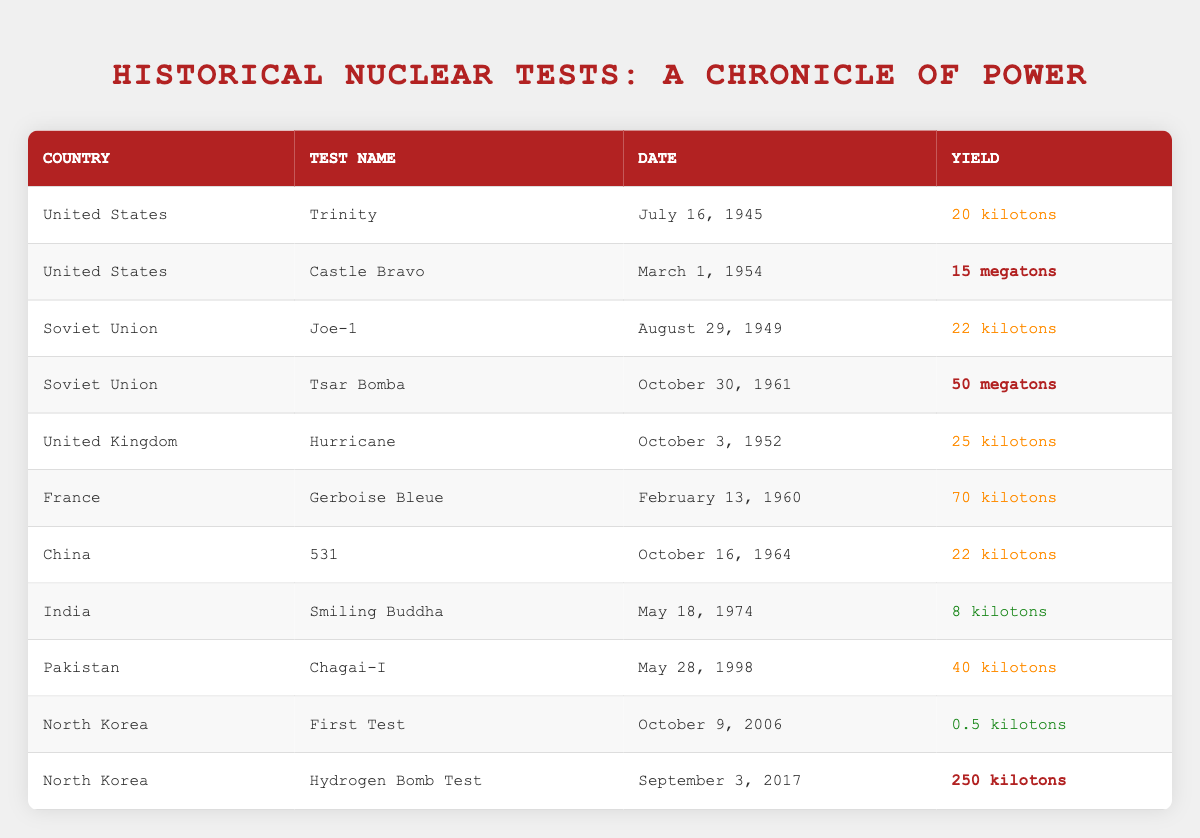What country conducted the first nuclear test? The first nuclear test listed in the table was the "Trinity" test conducted by the United States on July 16, 1945.
Answer: United States What is the yield of the "Tsar Bomba"? The yield of the "Tsar Bomba" test conducted by the Soviet Union on October 30, 1961, is 50 megatons.
Answer: 50 megatons Which test had the lowest yield? The "First Test" conducted by North Korea on October 9, 2006, had the lowest yield of 0.5 kilotons.
Answer: 0.5 kilotons What was the total yield of the tests conducted by the United States in the table? The total yield for U.S. tests is 20 kilotons (Trinity) + 15 megatons (Castle Bravo, converted to kilotons, is 15,000 kilotons), making a total of 15,020 kilotons.
Answer: 15,020 kilotons Is the yield of the "Hurricane" test greater than 20 kilotons? Yes, the "Hurricane" test has a yield of 25 kilotons, which is greater than 20 kilotons.
Answer: Yes What country tested a nuclear bomb with a yield exceeding 40 kilotons? The countries that tested bombs with yields exceeding 40 kilotons are the Soviet Union (Tsar Bomba, 50 megatons), France (Gerboise Bleue, 70 kilotons), and Pakistan (Chagai-I, 40 kilotons).
Answer: Soviet Union, France, Pakistan What is the average yield of all North Korean tests listed? There are two North Korean tests with yields of 0.5 kilotons (First Test) and 0.25 megatons (Hydrogen Bomb Test, converted to kilotons is 250 kilotons). Total yield is 0.5 + 250 = 250.5 kilotons, and the average is 250.5/2 = 125.25 kilotons.
Answer: 125.25 kilotons Did any country test nuclear weapons in the 1960s? Yes, several countries including the Soviet Union (Tsar Bomba), France (Gerboise Bleue), and China (531) conducted tests in the 1960s.
Answer: Yes Which test had the highest yield and what was it? The test with the highest yield is the "Tsar Bomba" conducted by the Soviet Union with a yield of 50 megatons.
Answer: Tsar Bomba, 50 megatons How many kilotons were released in France's Gerboise Bleue test? The yield of France's "Gerboise Bleue" test is listed as 70 kilotons.
Answer: 70 kilotons Which country had a test named "Castle Bravo" and what was its yield? The "Castle Bravo" test was conducted by the United States and had a yield of 15 megatons.
Answer: United States, 15 megatons 